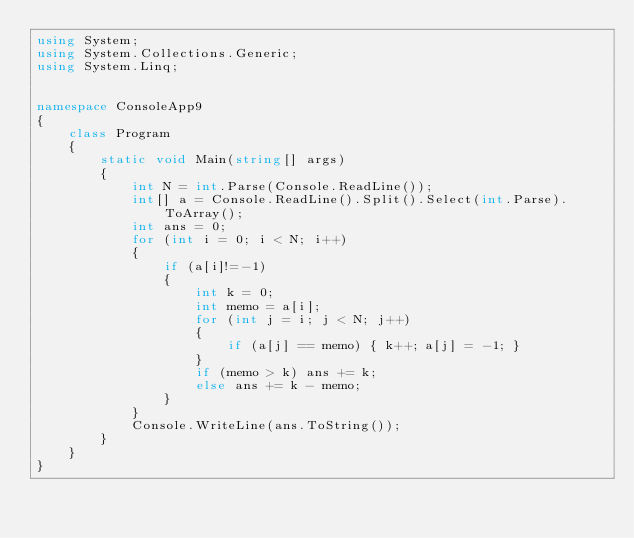Convert code to text. <code><loc_0><loc_0><loc_500><loc_500><_C#_>using System;
using System.Collections.Generic;
using System.Linq;


namespace ConsoleApp9
{
    class Program
    {
        static void Main(string[] args)
        {
            int N = int.Parse(Console.ReadLine());
            int[] a = Console.ReadLine().Split().Select(int.Parse).ToArray();
            int ans = 0;
            for (int i = 0; i < N; i++)
            {
                if (a[i]!=-1)
                {
                    int k = 0;
                    int memo = a[i];
                    for (int j = i; j < N; j++)
                    {
                        if (a[j] == memo) { k++; a[j] = -1; }
                    }
                    if (memo > k) ans += k;
                    else ans += k - memo;
                }
            }
            Console.WriteLine(ans.ToString());
        }
    }
}</code> 